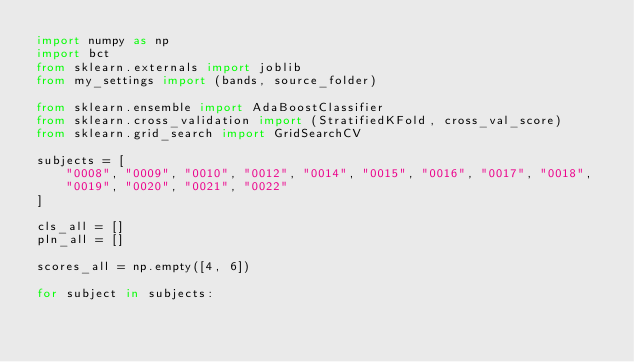Convert code to text. <code><loc_0><loc_0><loc_500><loc_500><_Python_>import numpy as np
import bct
from sklearn.externals import joblib
from my_settings import (bands, source_folder)

from sklearn.ensemble import AdaBoostClassifier
from sklearn.cross_validation import (StratifiedKFold, cross_val_score)
from sklearn.grid_search import GridSearchCV

subjects = [
    "0008", "0009", "0010", "0012", "0014", "0015", "0016", "0017", "0018",
    "0019", "0020", "0021", "0022"
]

cls_all = []
pln_all = []

scores_all = np.empty([4, 6])

for subject in subjects:</code> 